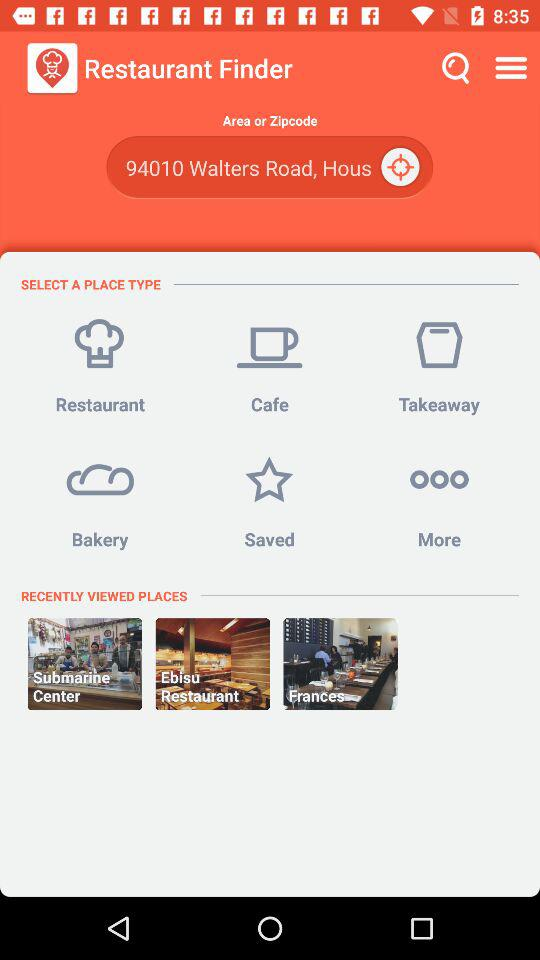What is the application name? The application name is "Restaurant Finder". 